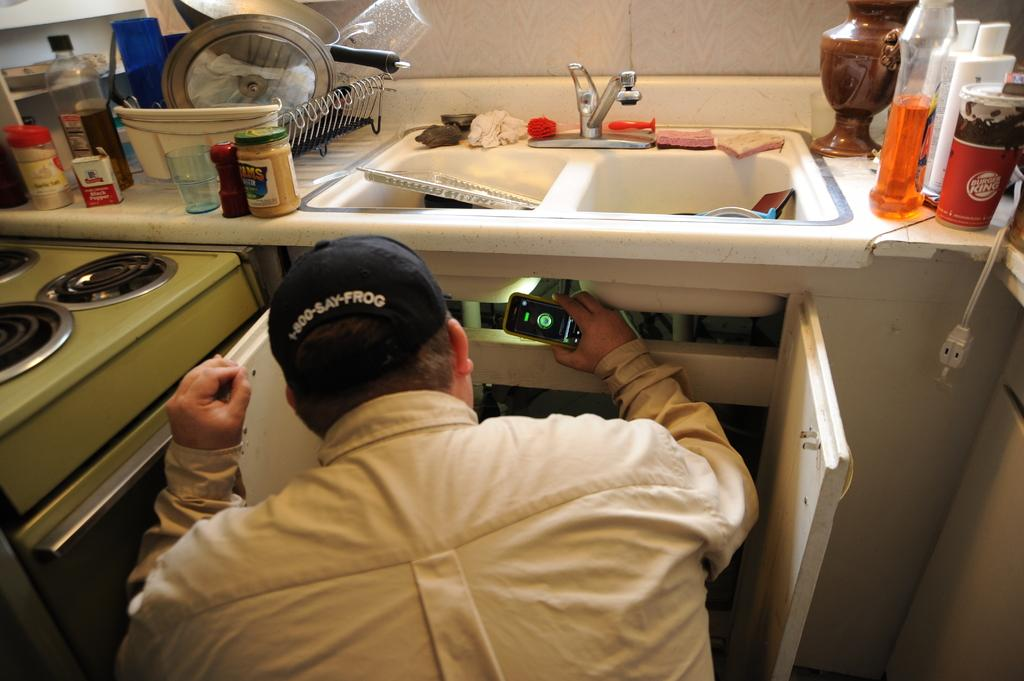<image>
Give a short and clear explanation of the subsequent image. A man wearing a 1-800-SAY-FROG hat inspects under a sink. 